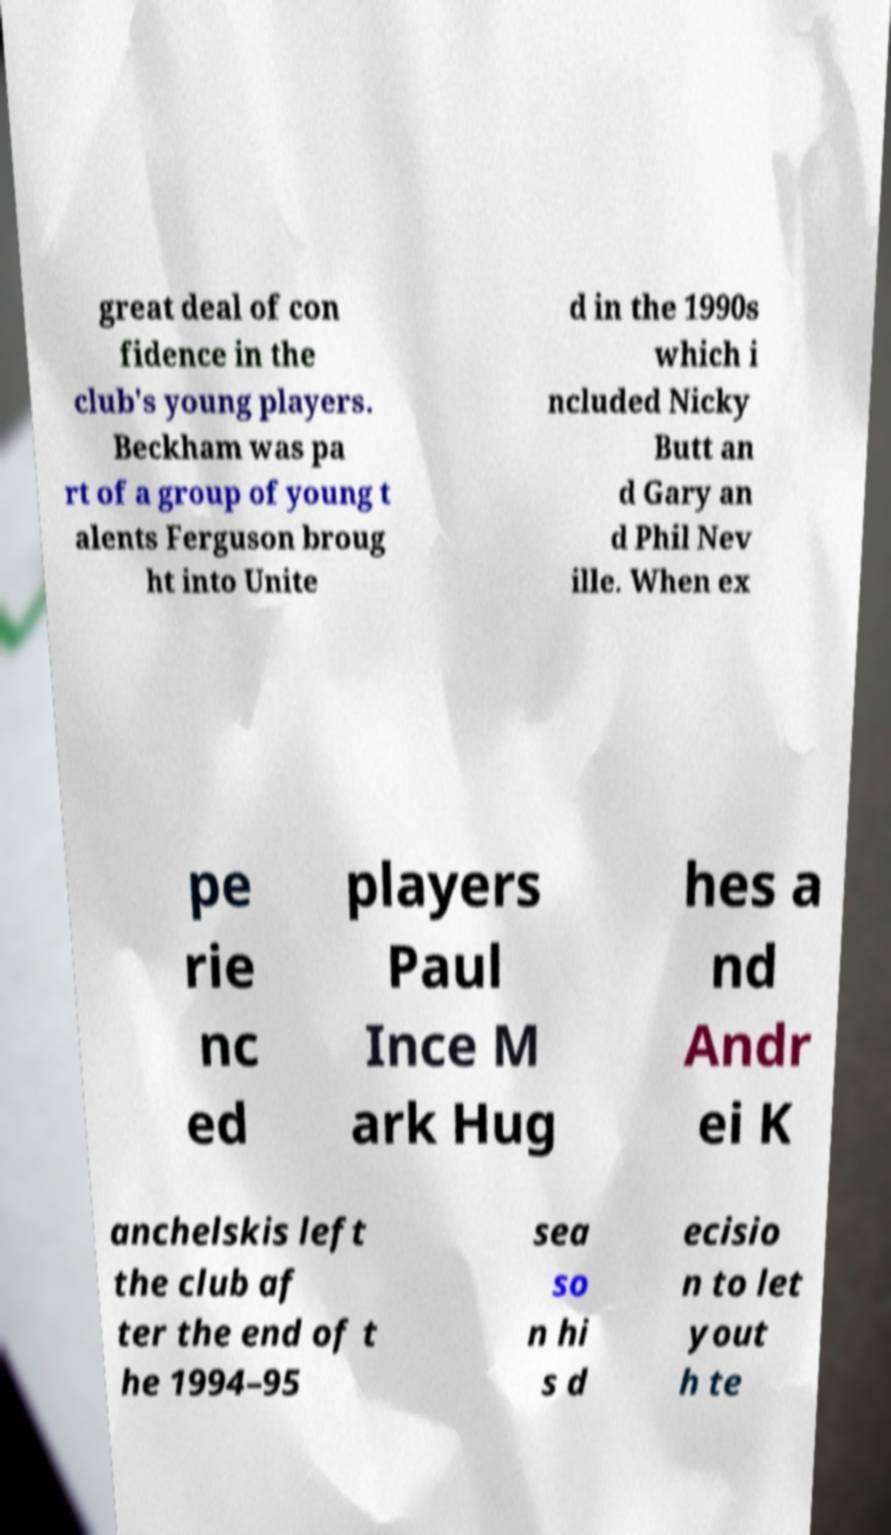There's text embedded in this image that I need extracted. Can you transcribe it verbatim? great deal of con fidence in the club's young players. Beckham was pa rt of a group of young t alents Ferguson broug ht into Unite d in the 1990s which i ncluded Nicky Butt an d Gary an d Phil Nev ille. When ex pe rie nc ed players Paul Ince M ark Hug hes a nd Andr ei K anchelskis left the club af ter the end of t he 1994–95 sea so n hi s d ecisio n to let yout h te 